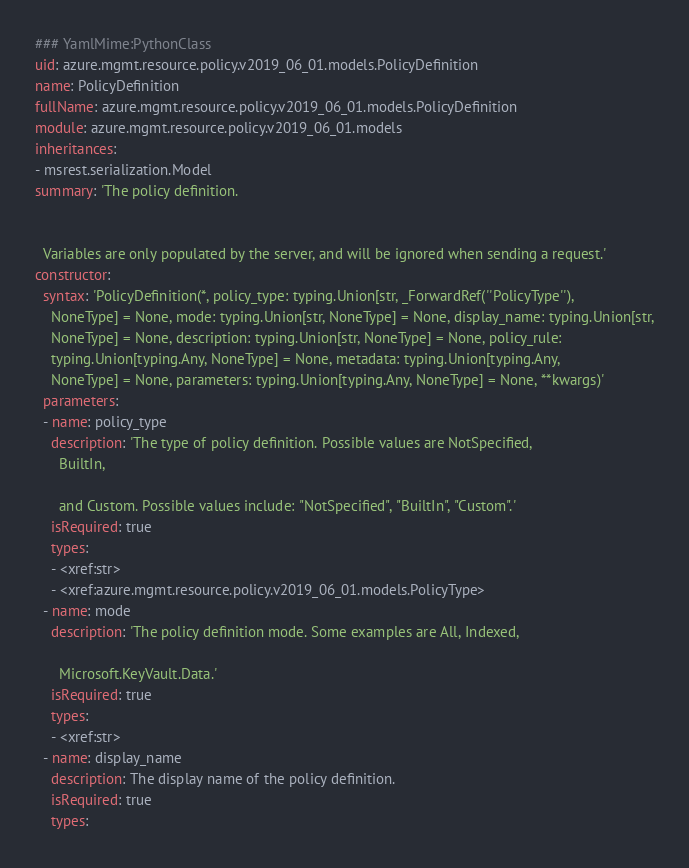Convert code to text. <code><loc_0><loc_0><loc_500><loc_500><_YAML_>### YamlMime:PythonClass
uid: azure.mgmt.resource.policy.v2019_06_01.models.PolicyDefinition
name: PolicyDefinition
fullName: azure.mgmt.resource.policy.v2019_06_01.models.PolicyDefinition
module: azure.mgmt.resource.policy.v2019_06_01.models
inheritances:
- msrest.serialization.Model
summary: 'The policy definition.


  Variables are only populated by the server, and will be ignored when sending a request.'
constructor:
  syntax: 'PolicyDefinition(*, policy_type: typing.Union[str, _ForwardRef(''PolicyType''),
    NoneType] = None, mode: typing.Union[str, NoneType] = None, display_name: typing.Union[str,
    NoneType] = None, description: typing.Union[str, NoneType] = None, policy_rule:
    typing.Union[typing.Any, NoneType] = None, metadata: typing.Union[typing.Any,
    NoneType] = None, parameters: typing.Union[typing.Any, NoneType] = None, **kwargs)'
  parameters:
  - name: policy_type
    description: 'The type of policy definition. Possible values are NotSpecified,
      BuiltIn,

      and Custom. Possible values include: "NotSpecified", "BuiltIn", "Custom".'
    isRequired: true
    types:
    - <xref:str>
    - <xref:azure.mgmt.resource.policy.v2019_06_01.models.PolicyType>
  - name: mode
    description: 'The policy definition mode. Some examples are All, Indexed,

      Microsoft.KeyVault.Data.'
    isRequired: true
    types:
    - <xref:str>
  - name: display_name
    description: The display name of the policy definition.
    isRequired: true
    types:</code> 